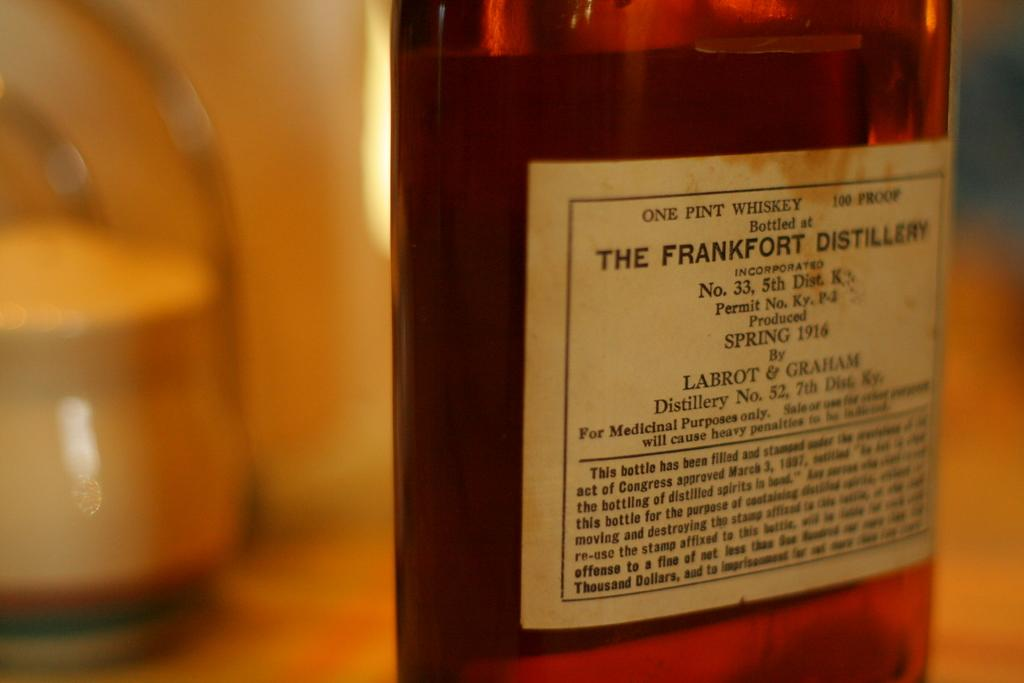What object can be seen in the image? There is a bottle in the image. What is the color of the bottle? The bottle is red in color. Are there any additional features on the bottle? Yes, there is a sticker on the bottle. Can you describe the sticker on the bottle? The sticker has many words on it. What type of plantation is visible in the image? There is no plantation present in the image; it features a red bottle with a sticker on it. Can you tell me the name of the secretary mentioned on the sticker? There is no secretary mentioned on the sticker, as it only has many words without any specific names or titles. 